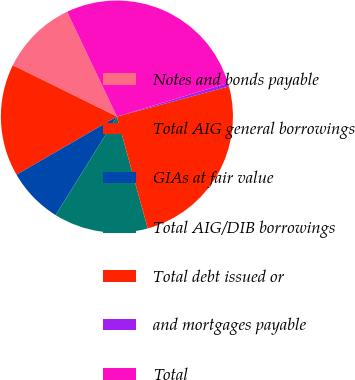Convert chart to OTSL. <chart><loc_0><loc_0><loc_500><loc_500><pie_chart><fcel>Notes and bonds payable<fcel>Total AIG general borrowings<fcel>GIAs at fair value<fcel>Total AIG/DIB borrowings<fcel>Total debt issued or<fcel>and mortgages payable<fcel>Total<nl><fcel>10.65%<fcel>15.64%<fcel>7.79%<fcel>13.14%<fcel>24.91%<fcel>0.48%<fcel>27.4%<nl></chart> 